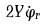Convert formula to latex. <formula><loc_0><loc_0><loc_500><loc_500>2 Y \dot { \varphi } _ { r }</formula> 